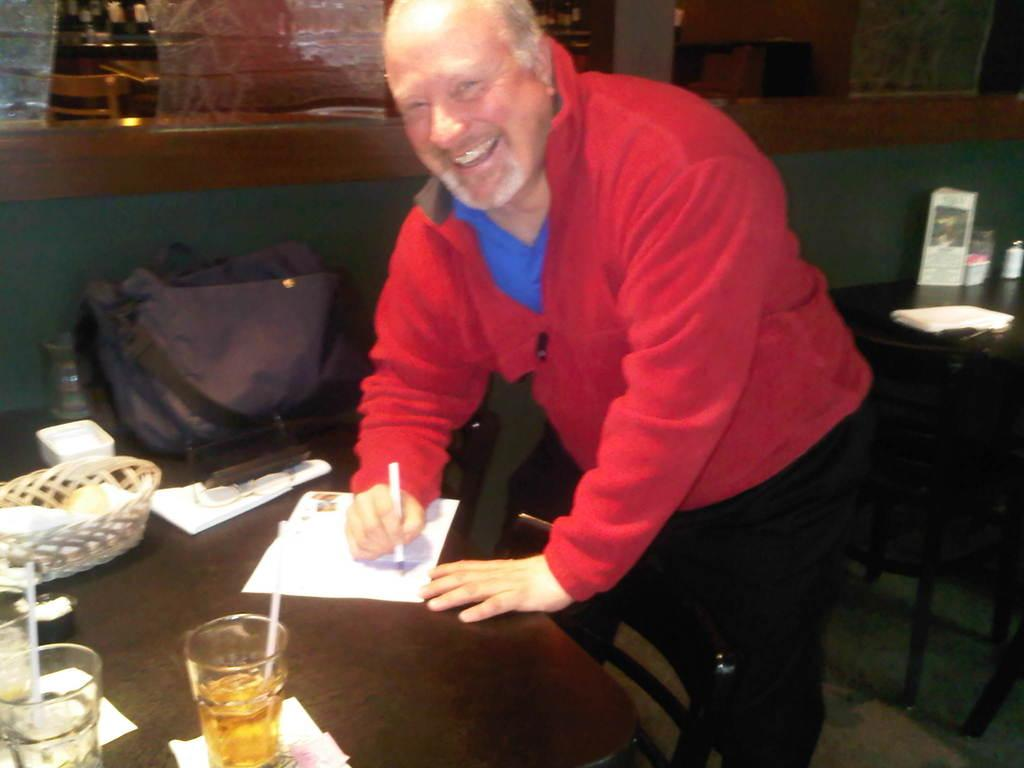What type of furniture is present in the image? There are chairs and tables in the image. What is the man in the image doing? The man is standing in the image. What is on the table in the image? There is a paper, a basket, and glasses on the table in the image. What type of instrument is the man playing in the image? There is no instrument present in the image, and the man is not playing any instrument. What type of drink is in the glasses on the table? The image does not provide information about the contents of the glasses, so we cannot determine if there is a drink in them. 